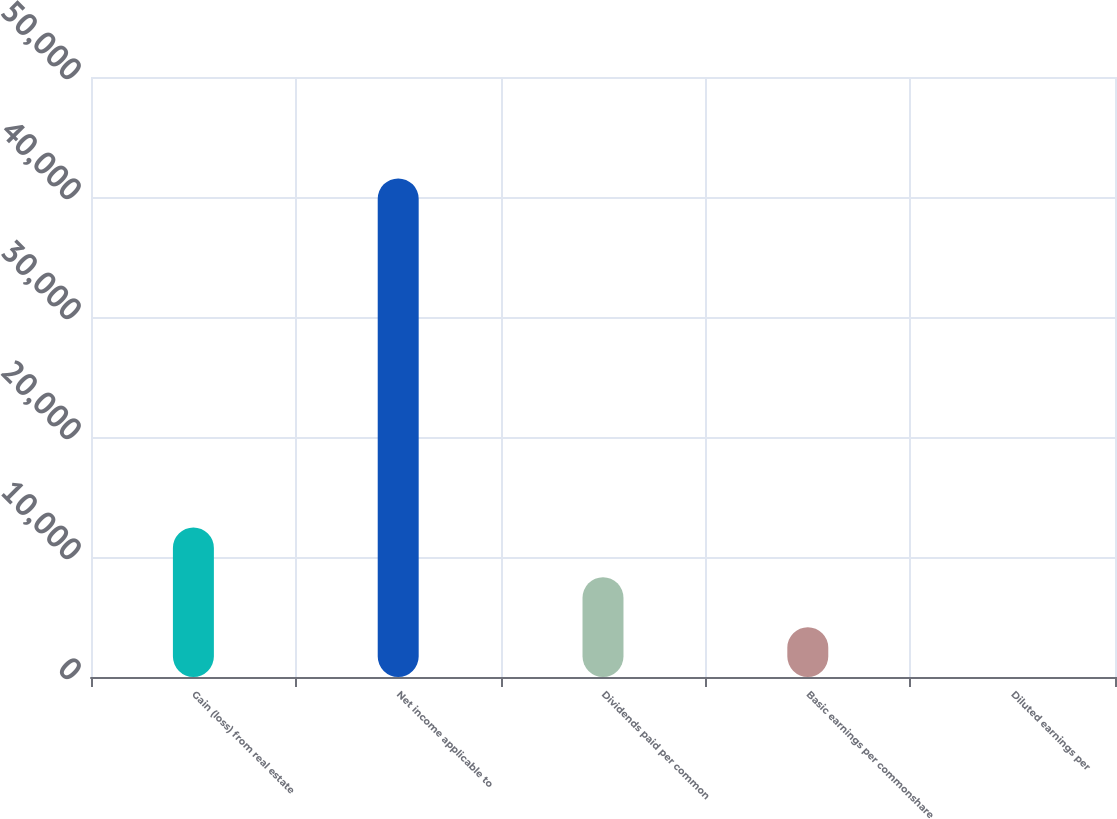Convert chart to OTSL. <chart><loc_0><loc_0><loc_500><loc_500><bar_chart><fcel>Gain (loss) from real estate<fcel>Net income applicable to<fcel>Dividends paid per common<fcel>Basic earnings per commonshare<fcel>Diluted earnings per<nl><fcel>12465.8<fcel>41552<fcel>8310.65<fcel>4155.48<fcel>0.31<nl></chart> 